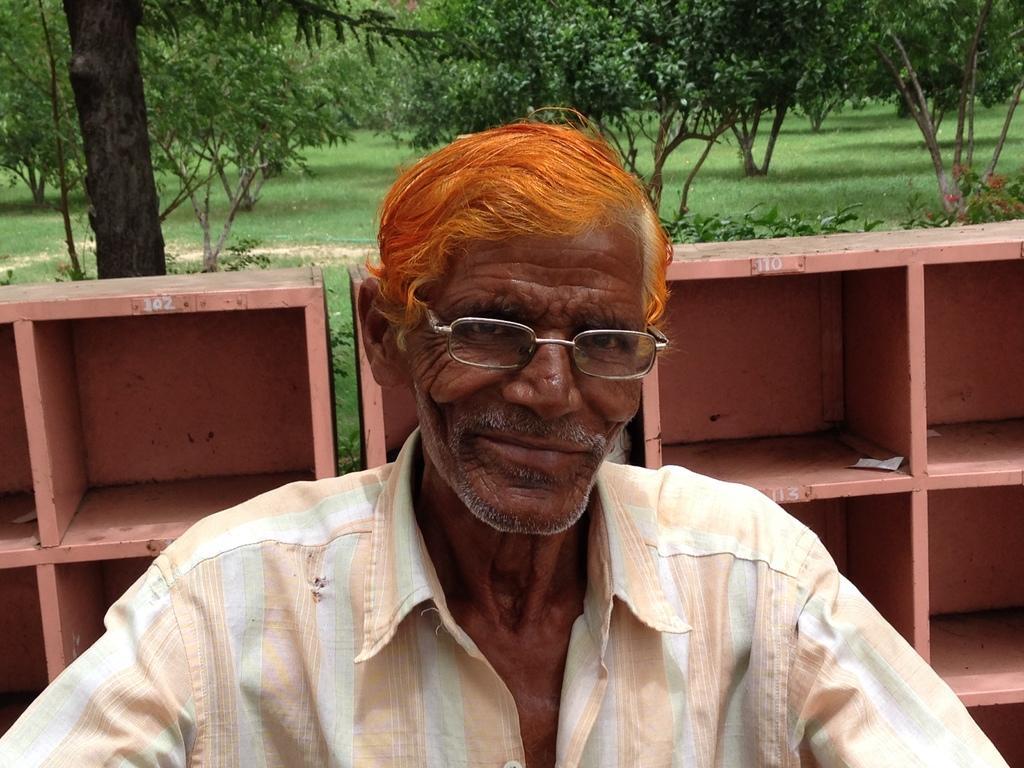In one or two sentences, can you explain what this image depicts? In this image we can see a man. In the background we can see trees, ground, plants, flowers and cupboards. 